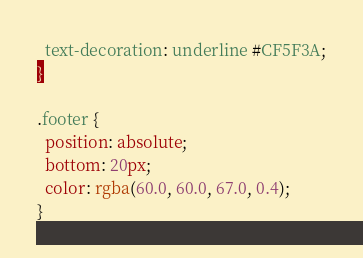<code> <loc_0><loc_0><loc_500><loc_500><_CSS_>  text-decoration: underline #CF5F3A;
}

.footer {
  position: absolute;
  bottom: 20px;
  color: rgba(60.0, 60.0, 67.0, 0.4);
}
</code> 